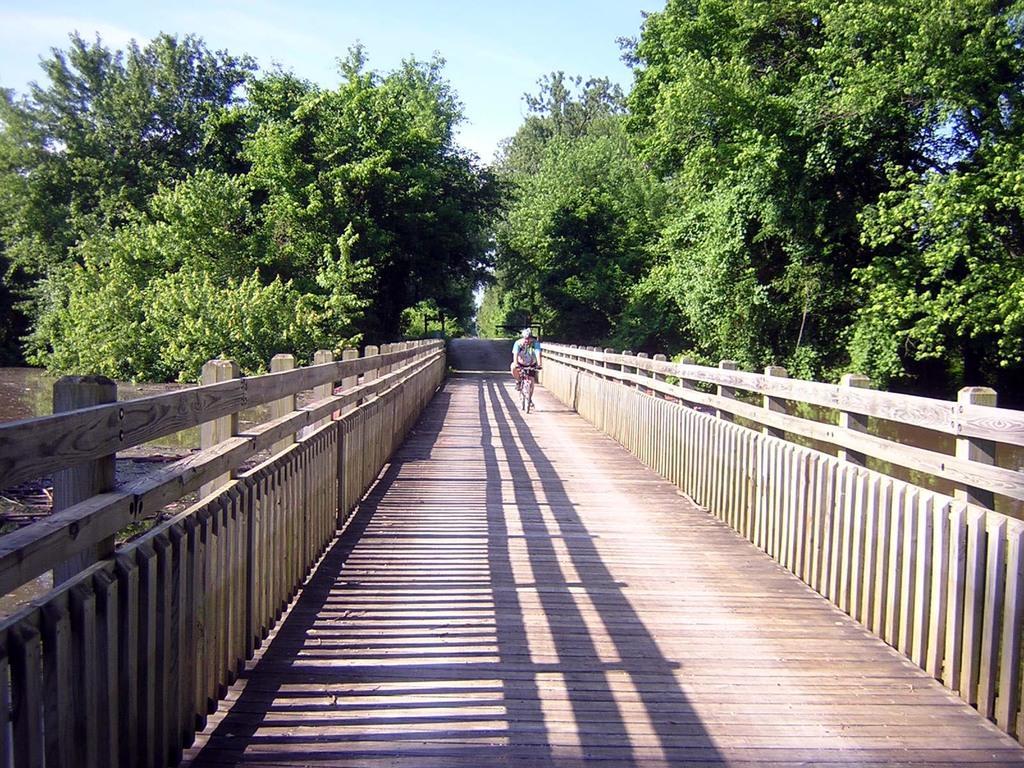In one or two sentences, can you explain what this image depicts? This image is clicked on a wooden bridge. There is a person riding bicycle on the bridge. On the either sides of the bridge there is the water on the ground. In the background there are trees. At the top there is the sky. 